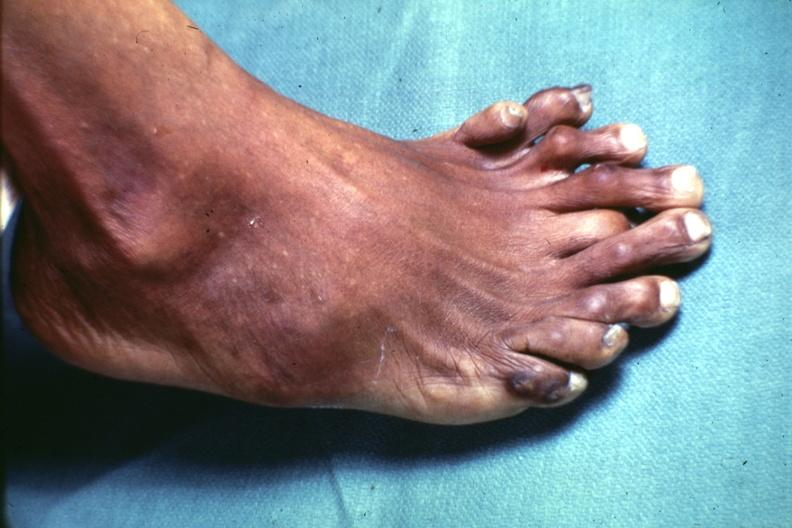s supernumerary digits present?
Answer the question using a single word or phrase. Yes 